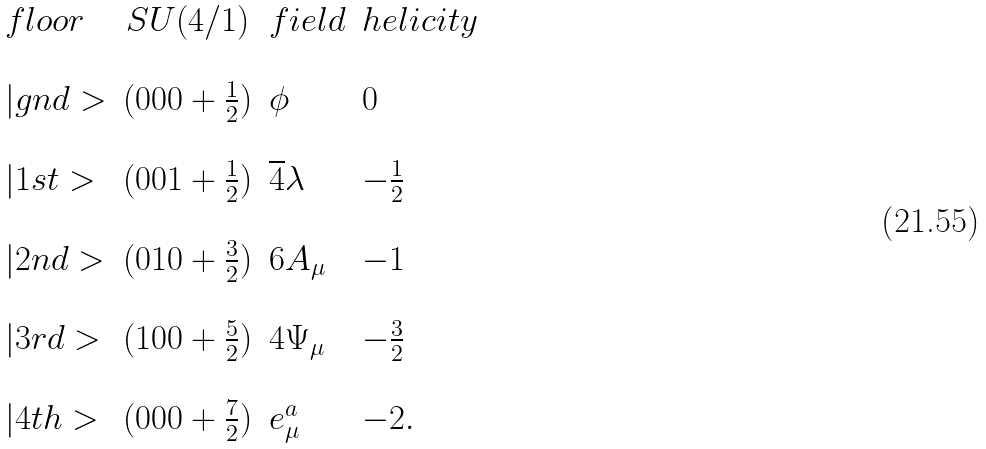Convert formula to latex. <formula><loc_0><loc_0><loc_500><loc_500>\begin{array} { l c l l } f l o o r & S U ( 4 / 1 ) & f i e l d & h e l i c i t y \\ \\ | g n d > & ( 0 0 0 + \frac { 1 } { 2 } ) & \phi & 0 \\ \\ | 1 s t > & ( 0 0 1 + \frac { 1 } { 2 } ) & \overline { 4 } \lambda & - \frac { 1 } { 2 } \\ \\ | 2 n d > & ( 0 1 0 + \frac { 3 } { 2 } ) & 6 A _ { \mu } & - 1 \\ \\ | 3 r d > & ( 1 0 0 + \frac { 5 } { 2 } ) & 4 \Psi _ { \mu } & - \frac { 3 } { 2 } \\ \\ | 4 t h > & ( 0 0 0 + \frac { 7 } { 2 } ) & e _ { \mu } ^ { a } & - 2 . \\ \end{array}</formula> 